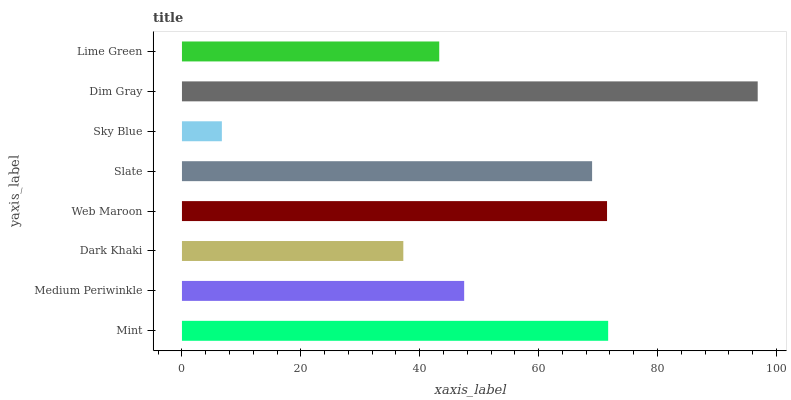Is Sky Blue the minimum?
Answer yes or no. Yes. Is Dim Gray the maximum?
Answer yes or no. Yes. Is Medium Periwinkle the minimum?
Answer yes or no. No. Is Medium Periwinkle the maximum?
Answer yes or no. No. Is Mint greater than Medium Periwinkle?
Answer yes or no. Yes. Is Medium Periwinkle less than Mint?
Answer yes or no. Yes. Is Medium Periwinkle greater than Mint?
Answer yes or no. No. Is Mint less than Medium Periwinkle?
Answer yes or no. No. Is Slate the high median?
Answer yes or no. Yes. Is Medium Periwinkle the low median?
Answer yes or no. Yes. Is Sky Blue the high median?
Answer yes or no. No. Is Sky Blue the low median?
Answer yes or no. No. 